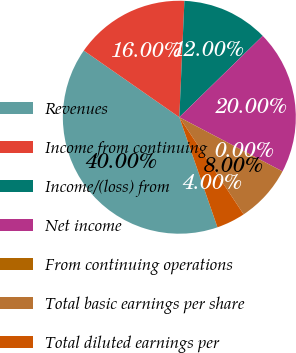Convert chart. <chart><loc_0><loc_0><loc_500><loc_500><pie_chart><fcel>Revenues<fcel>Income from continuing<fcel>Income/(loss) from<fcel>Net income<fcel>From continuing operations<fcel>Total basic earnings per share<fcel>Total diluted earnings per<nl><fcel>40.0%<fcel>16.0%<fcel>12.0%<fcel>20.0%<fcel>0.0%<fcel>8.0%<fcel>4.0%<nl></chart> 